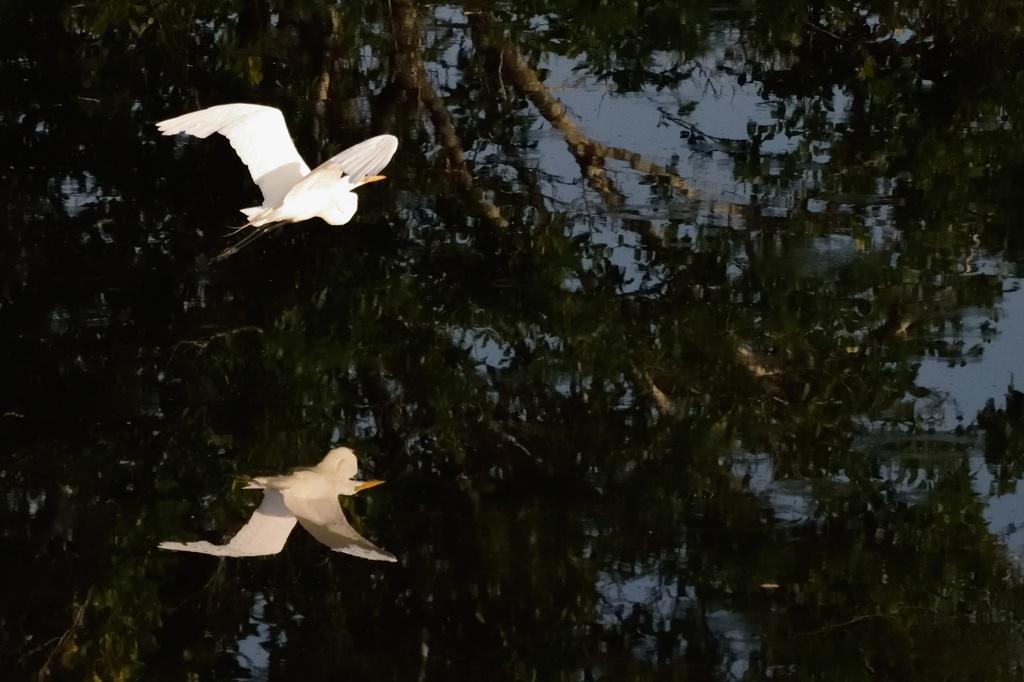Describe this image in one or two sentences. In this picture there is a bird flying. At the bottom there is water and there is reflection of tree on the water and there is a reflection of bird on the water. 